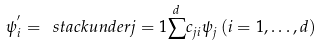<formula> <loc_0><loc_0><loc_500><loc_500>\psi _ { i } ^ { ^ { \prime } } = \ s t a c k u n d e r { j = 1 } { \stackrel { d } { \sum } } c _ { j i } \psi _ { j } \, ( i = 1 , \dots , d )</formula> 